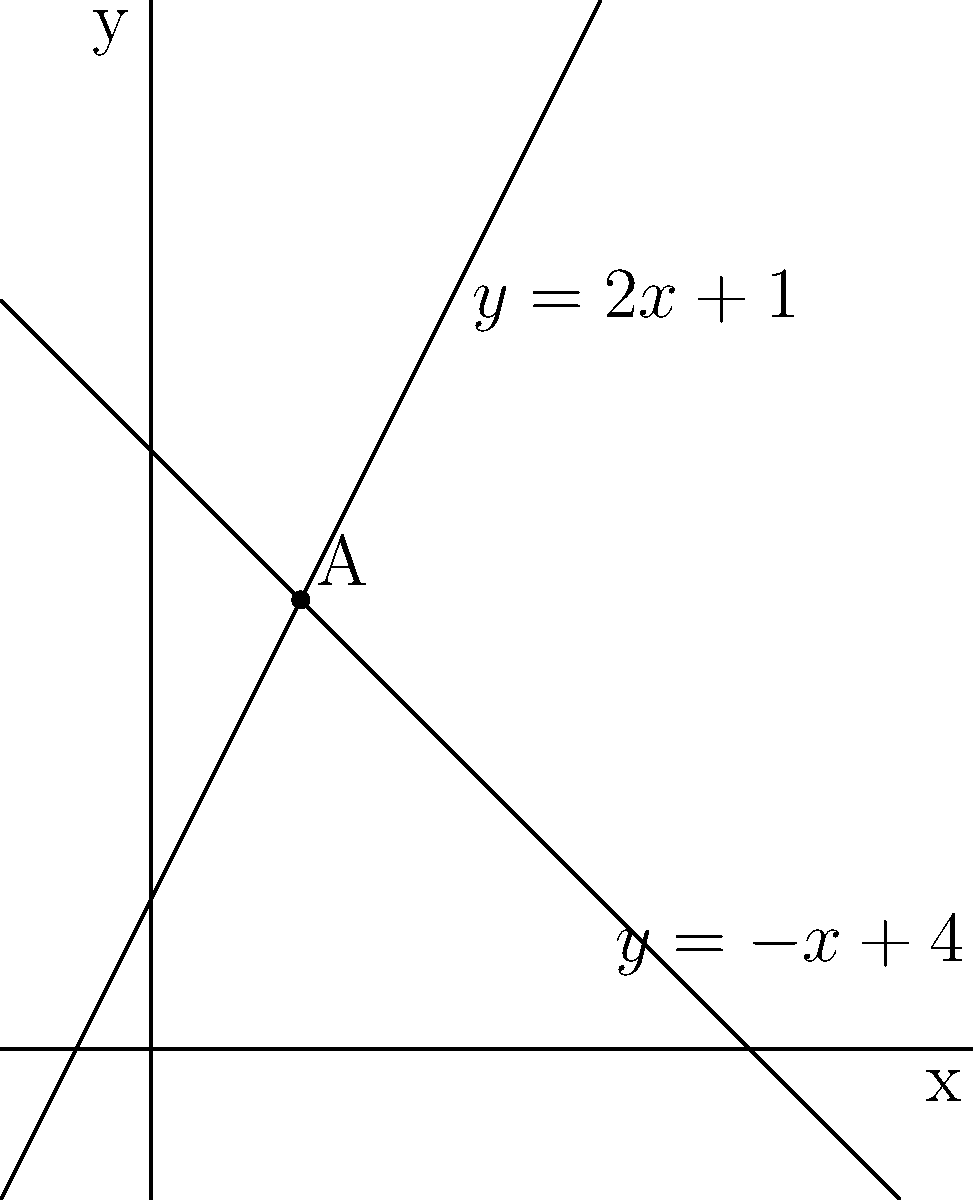In your latest novel, you're exploring the concept of intersecting storylines. To visualize this, you decide to represent two plot lines as linear equations on a coordinate plane. The protagonist's journey is represented by the equation $y = 2x + 1$, while the antagonist's path is given by $y = -x + 4$. At what point do these plot lines intersect, symbolizing a crucial moment in your story where the characters' paths cross? To find the intersection point of the two plot lines, we need to solve the system of equations:

1) $y = 2x + 1$ (protagonist's line)
2) $y = -x + 4$ (antagonist's line)

At the intersection point, the y-values will be equal. So we can set the right sides of the equations equal to each other:

3) $2x + 1 = -x + 4$

Now, let's solve for x:

4) $2x + x = 4 - 1$
5) $3x = 3$
6) $x = 1$

Now that we know the x-coordinate of the intersection point, we can substitute this value into either of the original equations to find the y-coordinate. Let's use the first equation:

7) $y = 2(1) + 1 = 2 + 1 = 3$

Therefore, the plot lines intersect at the point (1, 3). This point is labeled as A on the graph.

In the context of your story, this could represent a pivotal moment where the protagonist and antagonist meet or where their actions directly affect each other, occurring at a significant point in the narrative structure.
Answer: (1, 3) 